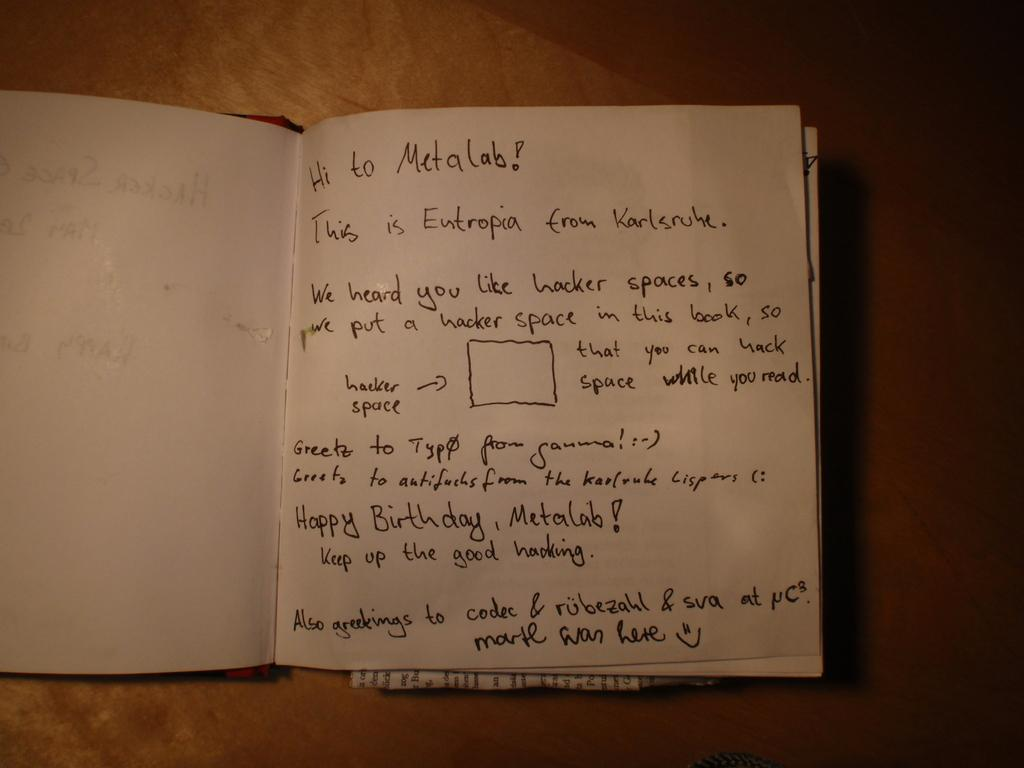Provide a one-sentence caption for the provided image. Textbook that is saying happy birthday to the Metalab. 